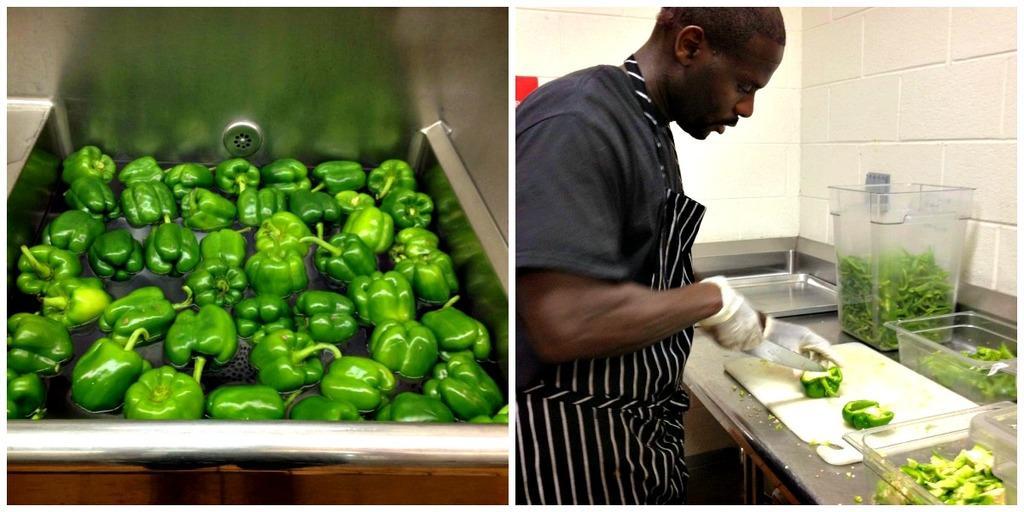Could you give a brief overview of what you see in this image? In this image we can see a collage of two pictures. On the left side, we can see a group of capsicum placed in water. On the right side, we can see a person wearing dress, holding a knife in his hand cutting a capsicum placed on a table. In the background, we can see a group of containers with food and a tray. 